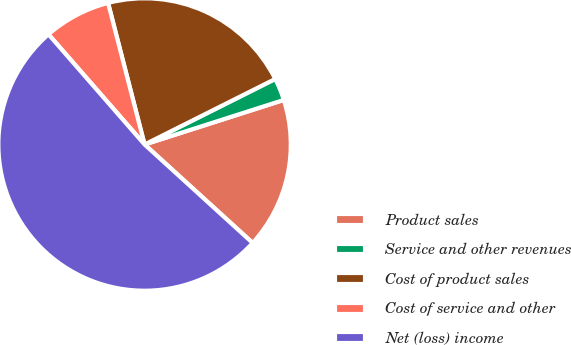<chart> <loc_0><loc_0><loc_500><loc_500><pie_chart><fcel>Product sales<fcel>Service and other revenues<fcel>Cost of product sales<fcel>Cost of service and other<fcel>Net (loss) income<nl><fcel>16.69%<fcel>2.47%<fcel>21.62%<fcel>7.4%<fcel>51.83%<nl></chart> 